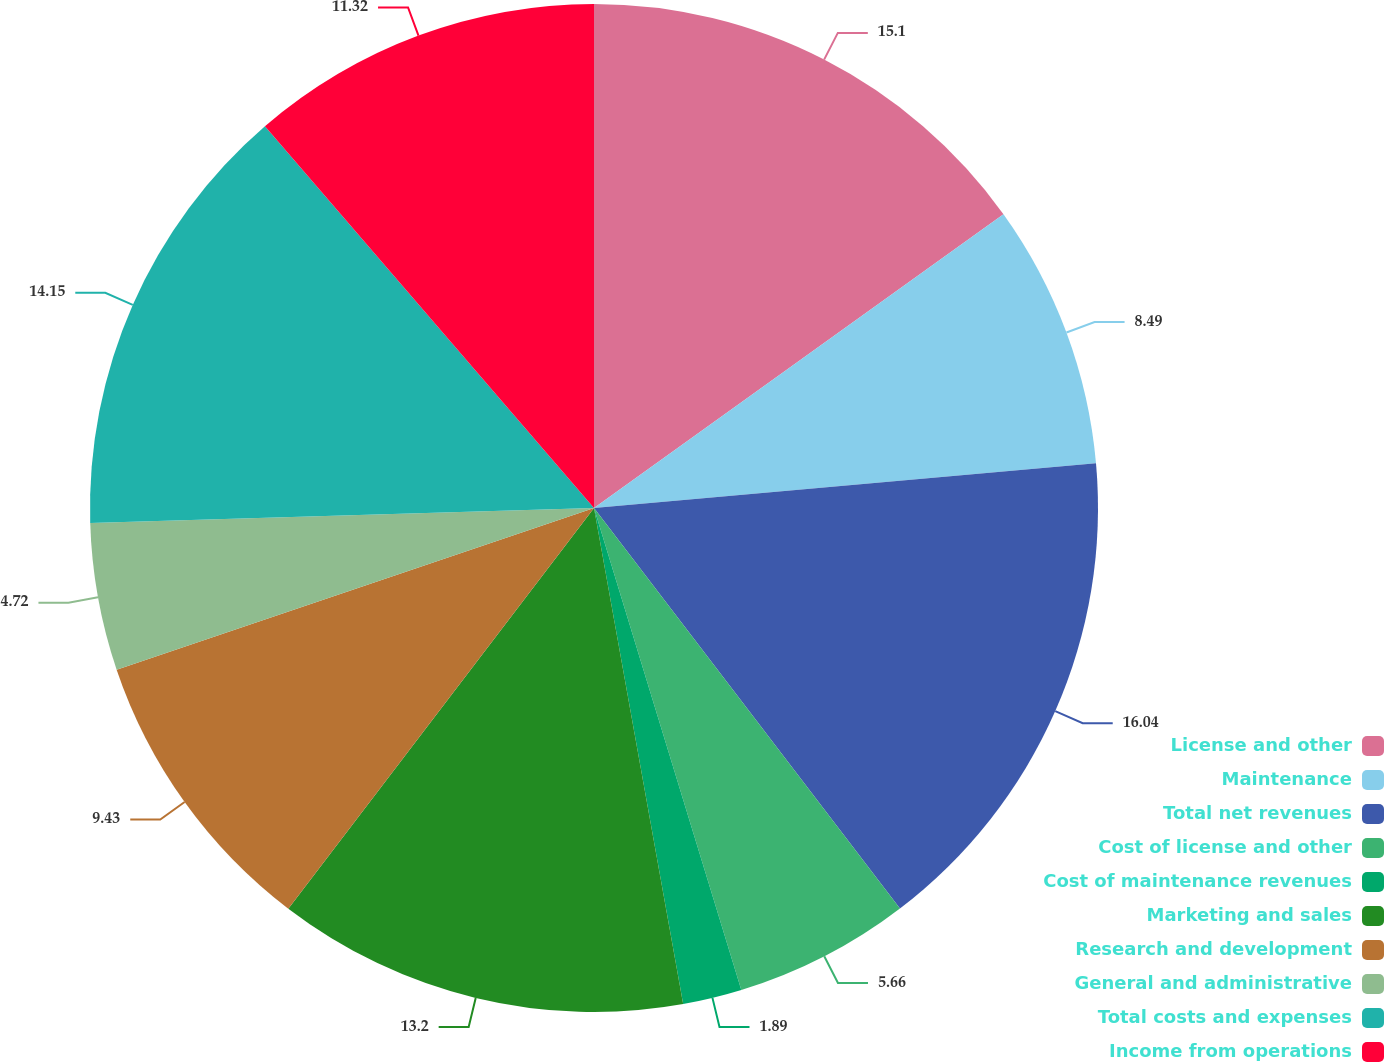<chart> <loc_0><loc_0><loc_500><loc_500><pie_chart><fcel>License and other<fcel>Maintenance<fcel>Total net revenues<fcel>Cost of license and other<fcel>Cost of maintenance revenues<fcel>Marketing and sales<fcel>Research and development<fcel>General and administrative<fcel>Total costs and expenses<fcel>Income from operations<nl><fcel>15.09%<fcel>8.49%<fcel>16.03%<fcel>5.66%<fcel>1.89%<fcel>13.2%<fcel>9.43%<fcel>4.72%<fcel>14.15%<fcel>11.32%<nl></chart> 